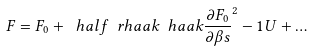<formula> <loc_0><loc_0><loc_500><loc_500>F = F _ { 0 } + \ h a l f \ r h a a k { \ h a a k { \frac { \partial F _ { 0 } } { \partial \beta s } } ^ { 2 } - 1 } U + \dots</formula> 